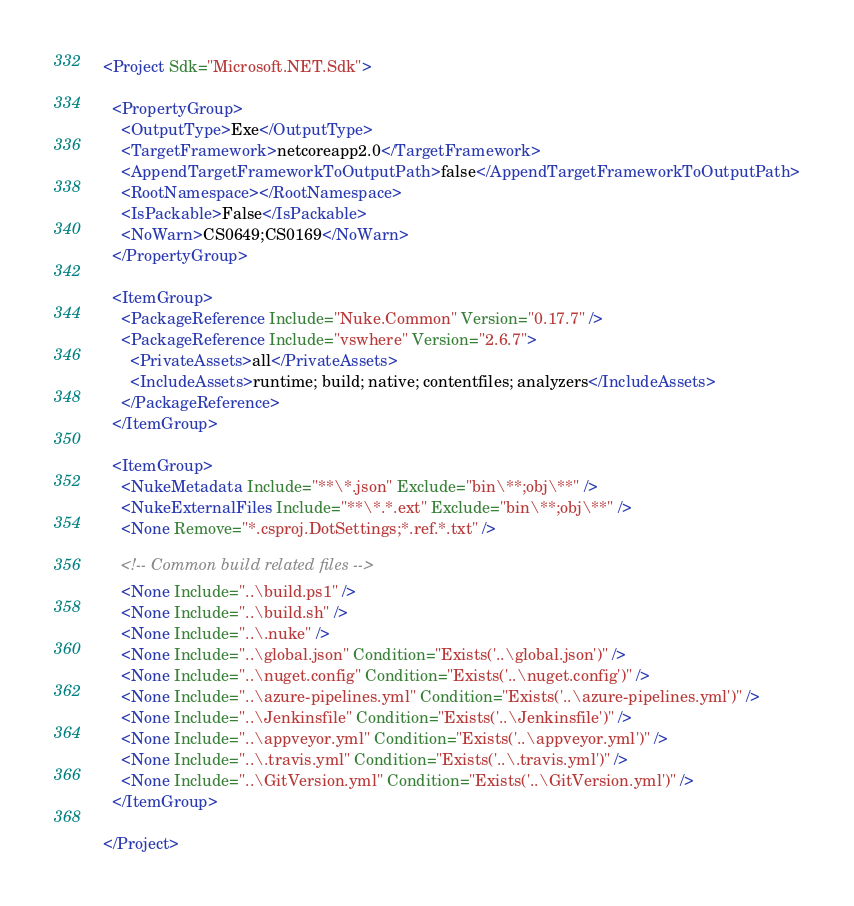Convert code to text. <code><loc_0><loc_0><loc_500><loc_500><_XML_><Project Sdk="Microsoft.NET.Sdk">

  <PropertyGroup>
    <OutputType>Exe</OutputType>
    <TargetFramework>netcoreapp2.0</TargetFramework>
    <AppendTargetFrameworkToOutputPath>false</AppendTargetFrameworkToOutputPath>
    <RootNamespace></RootNamespace>
    <IsPackable>False</IsPackable>
    <NoWarn>CS0649;CS0169</NoWarn>
  </PropertyGroup>

  <ItemGroup>
    <PackageReference Include="Nuke.Common" Version="0.17.7" />
    <PackageReference Include="vswhere" Version="2.6.7">
      <PrivateAssets>all</PrivateAssets>
      <IncludeAssets>runtime; build; native; contentfiles; analyzers</IncludeAssets>
    </PackageReference>
  </ItemGroup>

  <ItemGroup>
    <NukeMetadata Include="**\*.json" Exclude="bin\**;obj\**" />
    <NukeExternalFiles Include="**\*.*.ext" Exclude="bin\**;obj\**" />
    <None Remove="*.csproj.DotSettings;*.ref.*.txt" />
    
    <!-- Common build related files -->
    <None Include="..\build.ps1" />
    <None Include="..\build.sh" />
    <None Include="..\.nuke" />     
    <None Include="..\global.json" Condition="Exists('..\global.json')" />
    <None Include="..\nuget.config" Condition="Exists('..\nuget.config')" />
    <None Include="..\azure-pipelines.yml" Condition="Exists('..\azure-pipelines.yml')" />
    <None Include="..\Jenkinsfile" Condition="Exists('..\Jenkinsfile')" />
    <None Include="..\appveyor.yml" Condition="Exists('..\appveyor.yml')" />
    <None Include="..\.travis.yml" Condition="Exists('..\.travis.yml')" />
    <None Include="..\GitVersion.yml" Condition="Exists('..\GitVersion.yml')" />
  </ItemGroup>

</Project>
</code> 